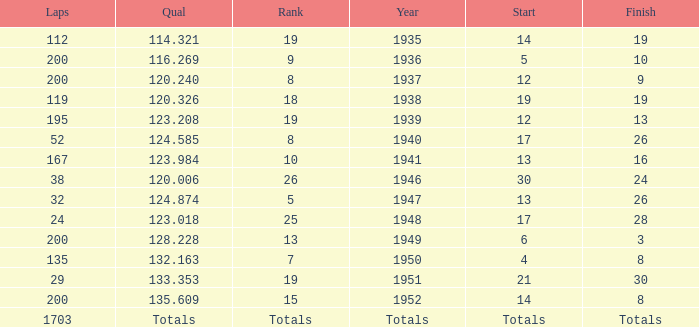With a Rank of 19, and a Start of 14, what was the finish? 19.0. 